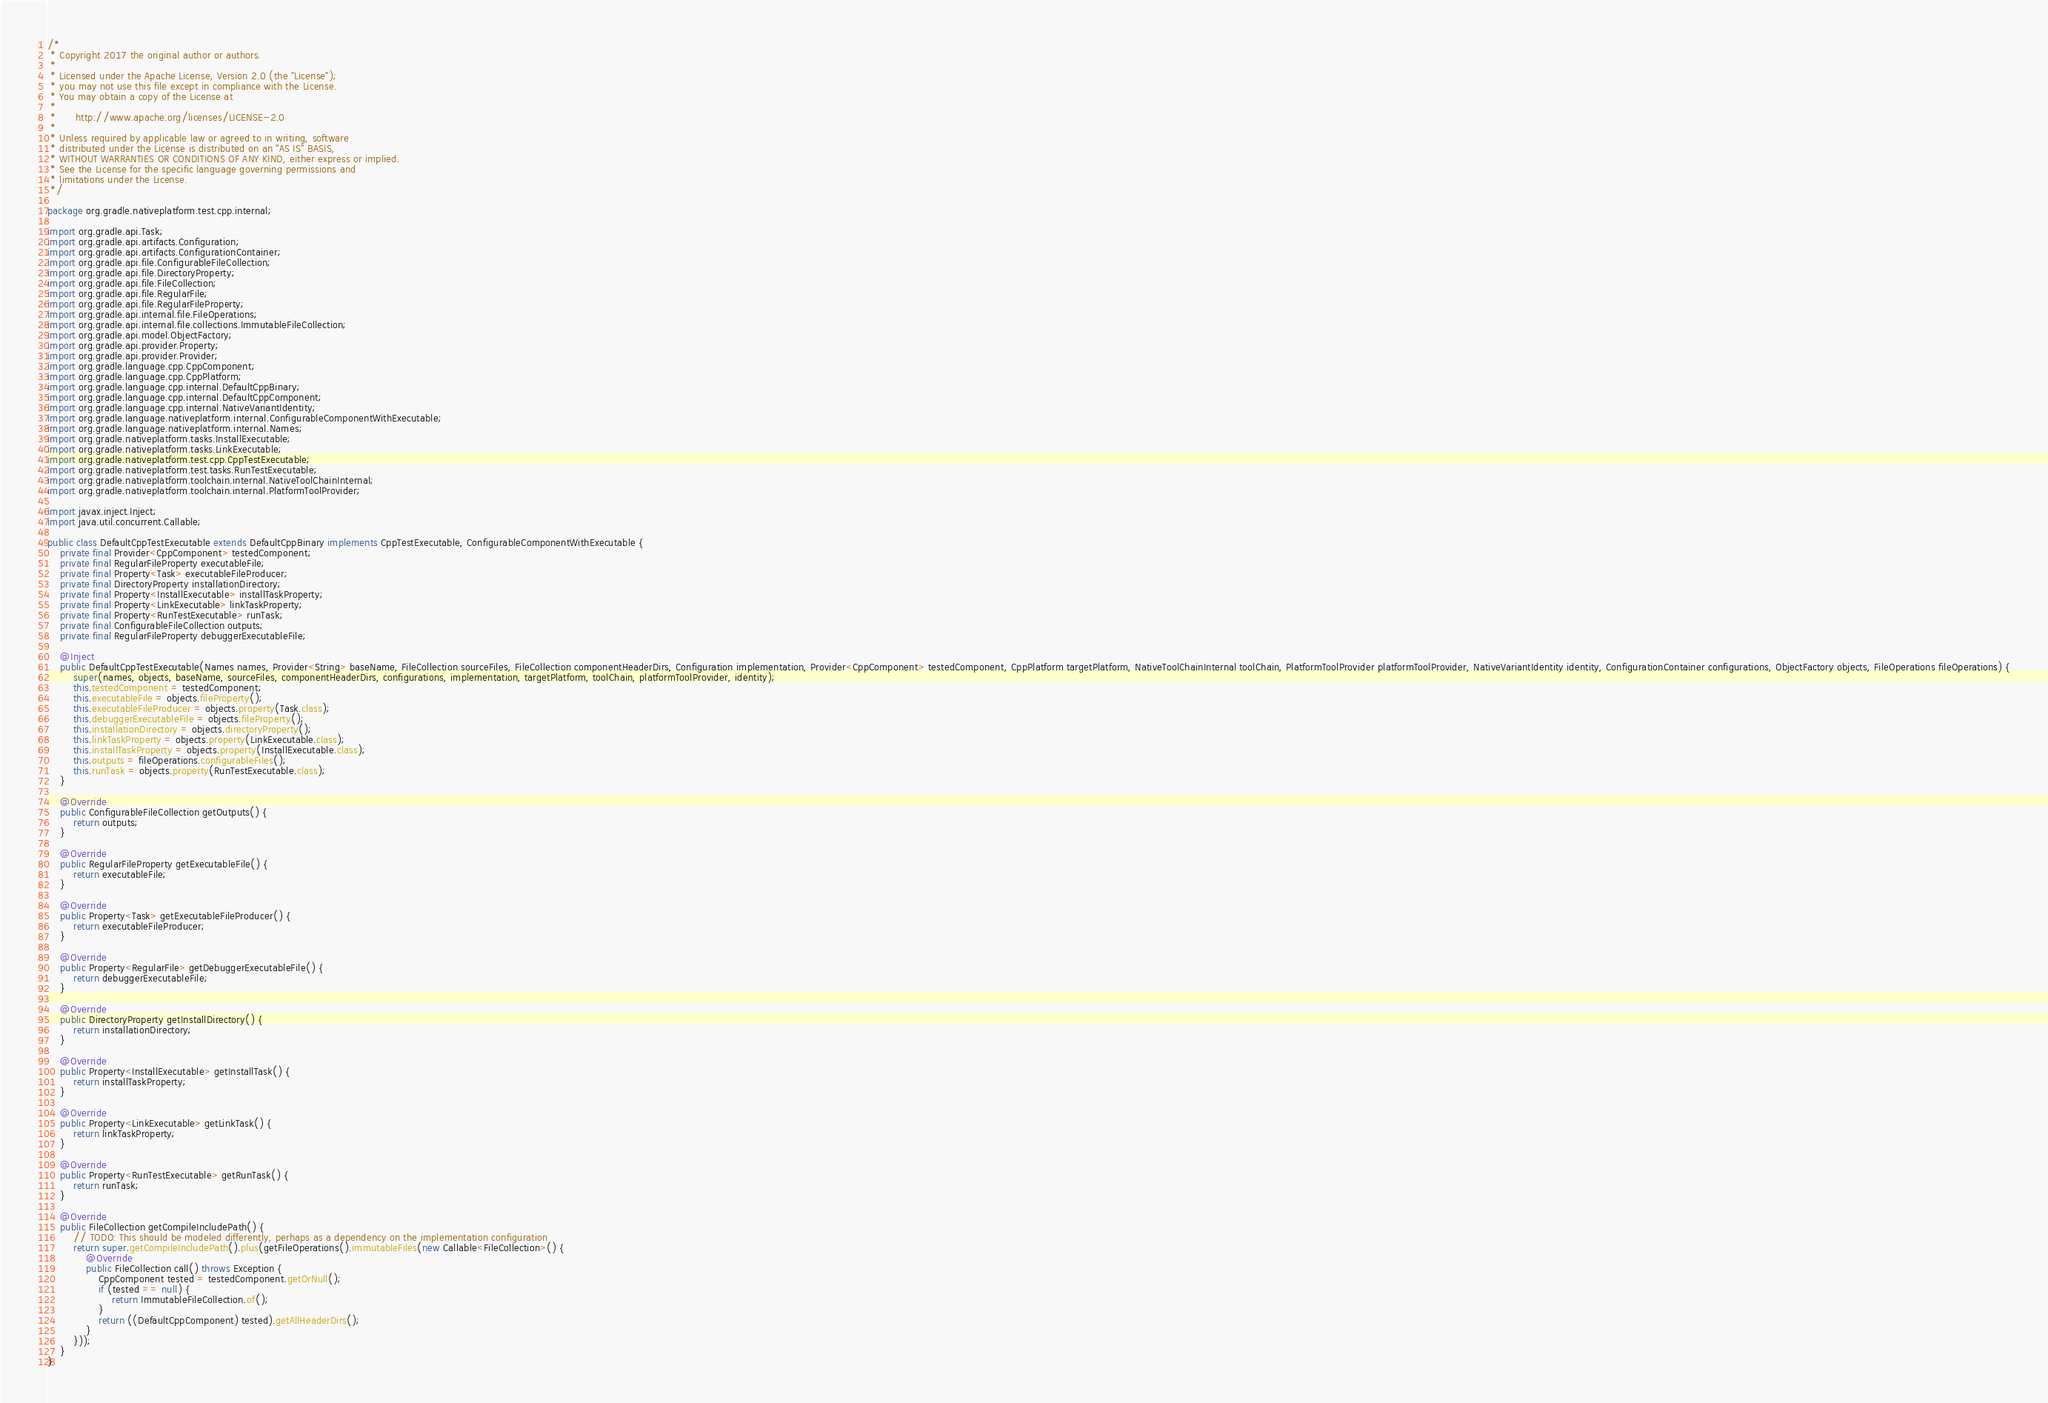Convert code to text. <code><loc_0><loc_0><loc_500><loc_500><_Java_>/*
 * Copyright 2017 the original author or authors.
 *
 * Licensed under the Apache License, Version 2.0 (the "License");
 * you may not use this file except in compliance with the License.
 * You may obtain a copy of the License at
 *
 *      http://www.apache.org/licenses/LICENSE-2.0
 *
 * Unless required by applicable law or agreed to in writing, software
 * distributed under the License is distributed on an "AS IS" BASIS,
 * WITHOUT WARRANTIES OR CONDITIONS OF ANY KIND, either express or implied.
 * See the License for the specific language governing permissions and
 * limitations under the License.
 */

package org.gradle.nativeplatform.test.cpp.internal;

import org.gradle.api.Task;
import org.gradle.api.artifacts.Configuration;
import org.gradle.api.artifacts.ConfigurationContainer;
import org.gradle.api.file.ConfigurableFileCollection;
import org.gradle.api.file.DirectoryProperty;
import org.gradle.api.file.FileCollection;
import org.gradle.api.file.RegularFile;
import org.gradle.api.file.RegularFileProperty;
import org.gradle.api.internal.file.FileOperations;
import org.gradle.api.internal.file.collections.ImmutableFileCollection;
import org.gradle.api.model.ObjectFactory;
import org.gradle.api.provider.Property;
import org.gradle.api.provider.Provider;
import org.gradle.language.cpp.CppComponent;
import org.gradle.language.cpp.CppPlatform;
import org.gradle.language.cpp.internal.DefaultCppBinary;
import org.gradle.language.cpp.internal.DefaultCppComponent;
import org.gradle.language.cpp.internal.NativeVariantIdentity;
import org.gradle.language.nativeplatform.internal.ConfigurableComponentWithExecutable;
import org.gradle.language.nativeplatform.internal.Names;
import org.gradle.nativeplatform.tasks.InstallExecutable;
import org.gradle.nativeplatform.tasks.LinkExecutable;
import org.gradle.nativeplatform.test.cpp.CppTestExecutable;
import org.gradle.nativeplatform.test.tasks.RunTestExecutable;
import org.gradle.nativeplatform.toolchain.internal.NativeToolChainInternal;
import org.gradle.nativeplatform.toolchain.internal.PlatformToolProvider;

import javax.inject.Inject;
import java.util.concurrent.Callable;

public class DefaultCppTestExecutable extends DefaultCppBinary implements CppTestExecutable, ConfigurableComponentWithExecutable {
    private final Provider<CppComponent> testedComponent;
    private final RegularFileProperty executableFile;
    private final Property<Task> executableFileProducer;
    private final DirectoryProperty installationDirectory;
    private final Property<InstallExecutable> installTaskProperty;
    private final Property<LinkExecutable> linkTaskProperty;
    private final Property<RunTestExecutable> runTask;
    private final ConfigurableFileCollection outputs;
    private final RegularFileProperty debuggerExecutableFile;

    @Inject
    public DefaultCppTestExecutable(Names names, Provider<String> baseName, FileCollection sourceFiles, FileCollection componentHeaderDirs, Configuration implementation, Provider<CppComponent> testedComponent, CppPlatform targetPlatform, NativeToolChainInternal toolChain, PlatformToolProvider platformToolProvider, NativeVariantIdentity identity, ConfigurationContainer configurations, ObjectFactory objects, FileOperations fileOperations) {
        super(names, objects, baseName, sourceFiles, componentHeaderDirs, configurations, implementation, targetPlatform, toolChain, platformToolProvider, identity);
        this.testedComponent = testedComponent;
        this.executableFile = objects.fileProperty();
        this.executableFileProducer = objects.property(Task.class);
        this.debuggerExecutableFile = objects.fileProperty();
        this.installationDirectory = objects.directoryProperty();
        this.linkTaskProperty = objects.property(LinkExecutable.class);
        this.installTaskProperty = objects.property(InstallExecutable.class);
        this.outputs = fileOperations.configurableFiles();
        this.runTask = objects.property(RunTestExecutable.class);
    }

    @Override
    public ConfigurableFileCollection getOutputs() {
        return outputs;
    }

    @Override
    public RegularFileProperty getExecutableFile() {
        return executableFile;
    }

    @Override
    public Property<Task> getExecutableFileProducer() {
        return executableFileProducer;
    }

    @Override
    public Property<RegularFile> getDebuggerExecutableFile() {
        return debuggerExecutableFile;
    }

    @Override
    public DirectoryProperty getInstallDirectory() {
        return installationDirectory;
    }

    @Override
    public Property<InstallExecutable> getInstallTask() {
        return installTaskProperty;
    }

    @Override
    public Property<LinkExecutable> getLinkTask() {
        return linkTaskProperty;
    }

    @Override
    public Property<RunTestExecutable> getRunTask() {
        return runTask;
    }

    @Override
    public FileCollection getCompileIncludePath() {
        // TODO: This should be modeled differently, perhaps as a dependency on the implementation configuration
        return super.getCompileIncludePath().plus(getFileOperations().immutableFiles(new Callable<FileCollection>() {
            @Override
            public FileCollection call() throws Exception {
                CppComponent tested = testedComponent.getOrNull();
                if (tested == null) {
                    return ImmutableFileCollection.of();
                }
                return ((DefaultCppComponent) tested).getAllHeaderDirs();
            }
        }));
    }
}
</code> 